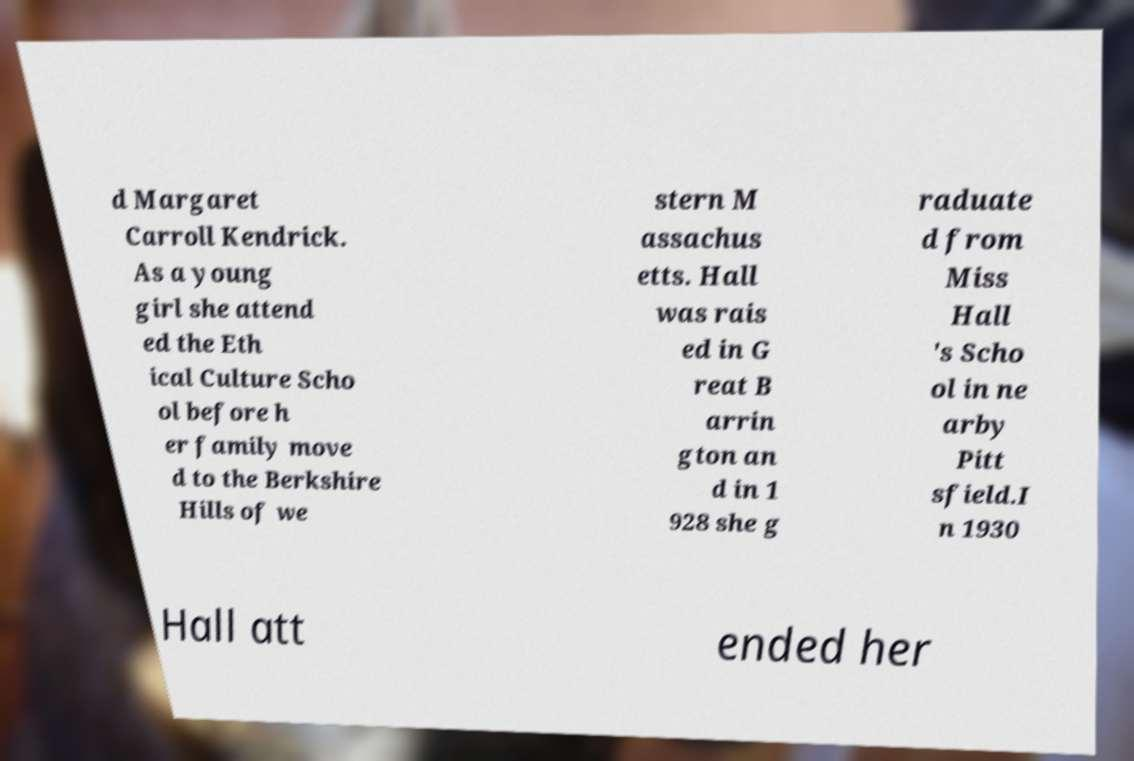Could you extract and type out the text from this image? d Margaret Carroll Kendrick. As a young girl she attend ed the Eth ical Culture Scho ol before h er family move d to the Berkshire Hills of we stern M assachus etts. Hall was rais ed in G reat B arrin gton an d in 1 928 she g raduate d from Miss Hall 's Scho ol in ne arby Pitt sfield.I n 1930 Hall att ended her 